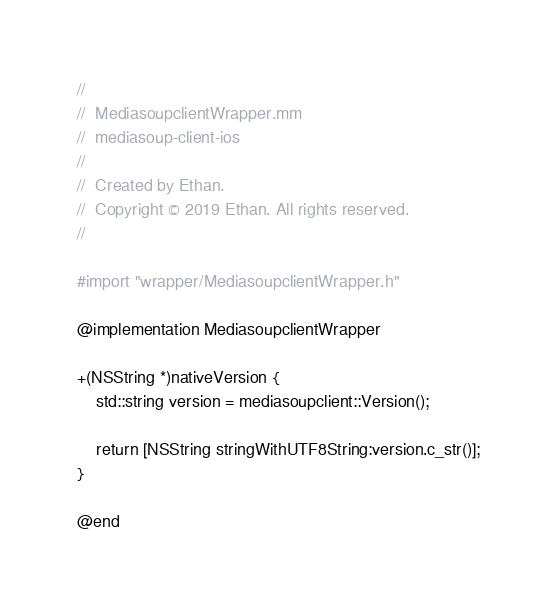<code> <loc_0><loc_0><loc_500><loc_500><_ObjectiveC_>//
//  MediasoupclientWrapper.mm
//  mediasoup-client-ios
//
//  Created by Ethan.
//  Copyright © 2019 Ethan. All rights reserved.
//

#import "wrapper/MediasoupclientWrapper.h"

@implementation MediasoupclientWrapper

+(NSString *)nativeVersion {
    std::string version = mediasoupclient::Version();
    
    return [NSString stringWithUTF8String:version.c_str()];
}

@end
</code> 